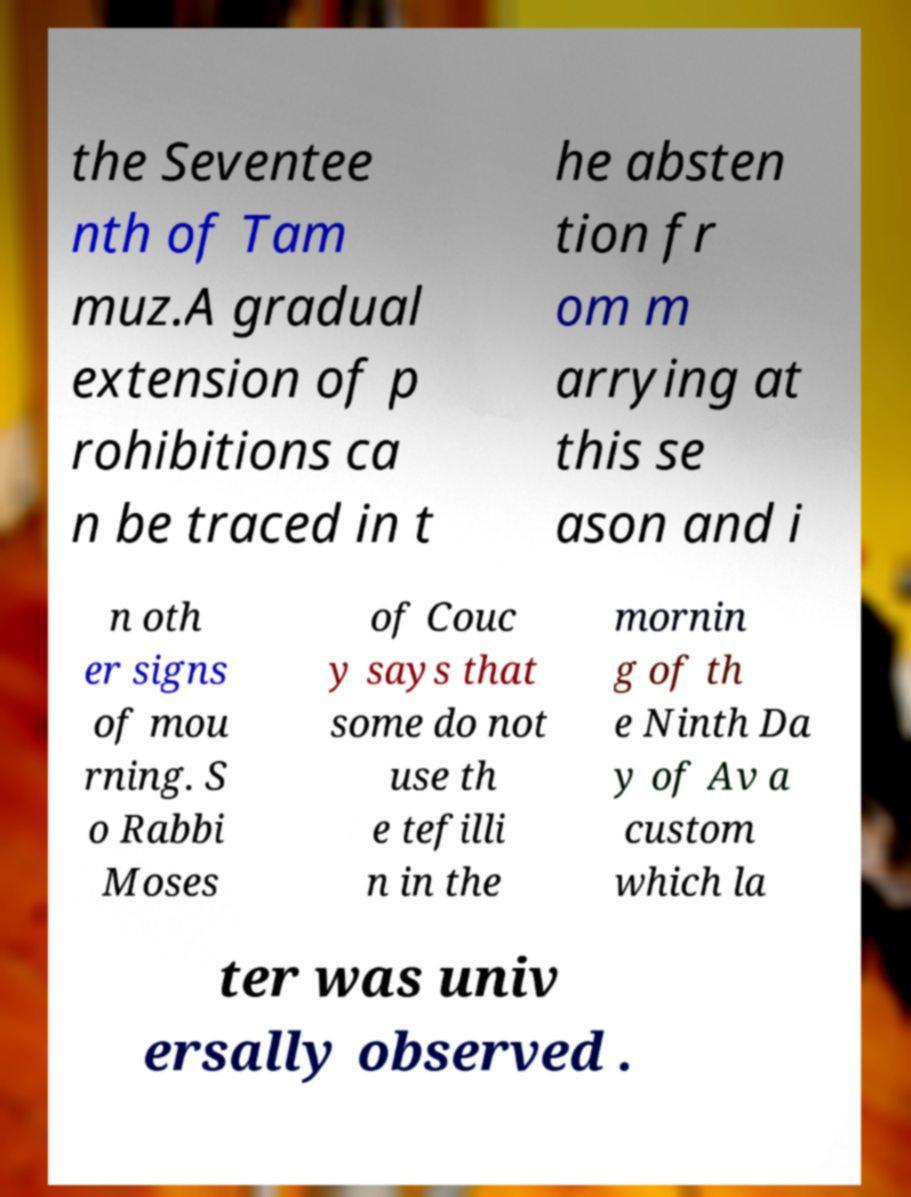There's text embedded in this image that I need extracted. Can you transcribe it verbatim? the Seventee nth of Tam muz.A gradual extension of p rohibitions ca n be traced in t he absten tion fr om m arrying at this se ason and i n oth er signs of mou rning. S o Rabbi Moses of Couc y says that some do not use th e tefilli n in the mornin g of th e Ninth Da y of Av a custom which la ter was univ ersally observed . 